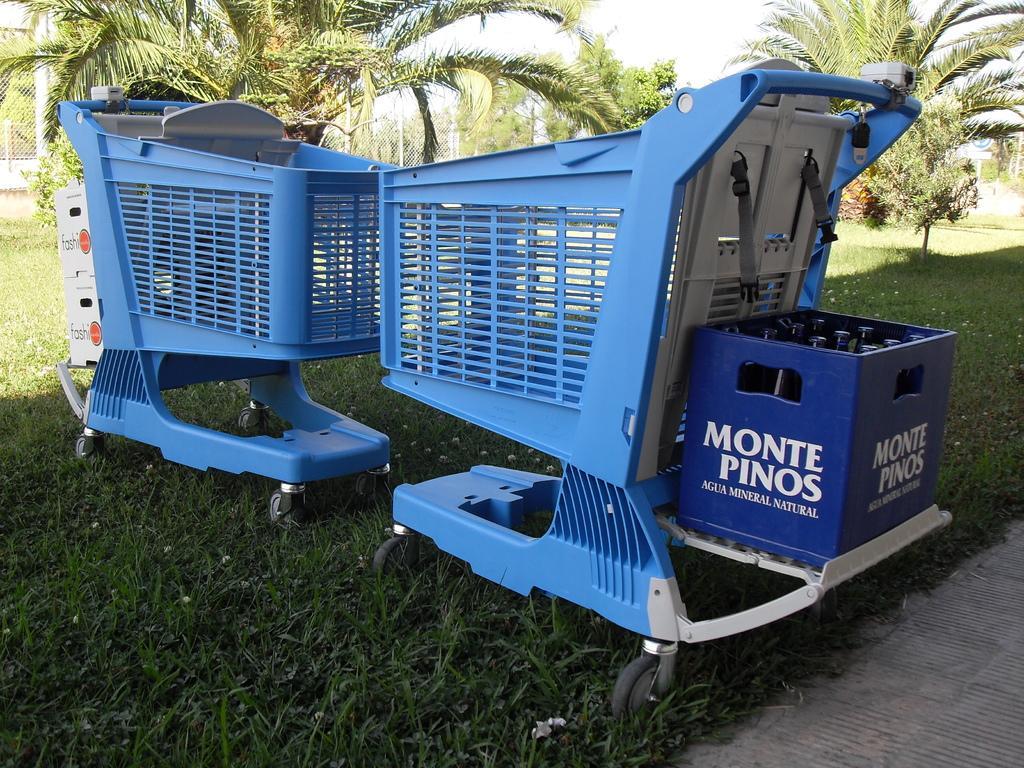Could you give a brief overview of what you see in this image? In this picture, we see the shopping carts in blue color. On the right side, we see the cool drink case in blue color. At the bottom, we see the grass and the pavement. There are trees and a fence in the background. 